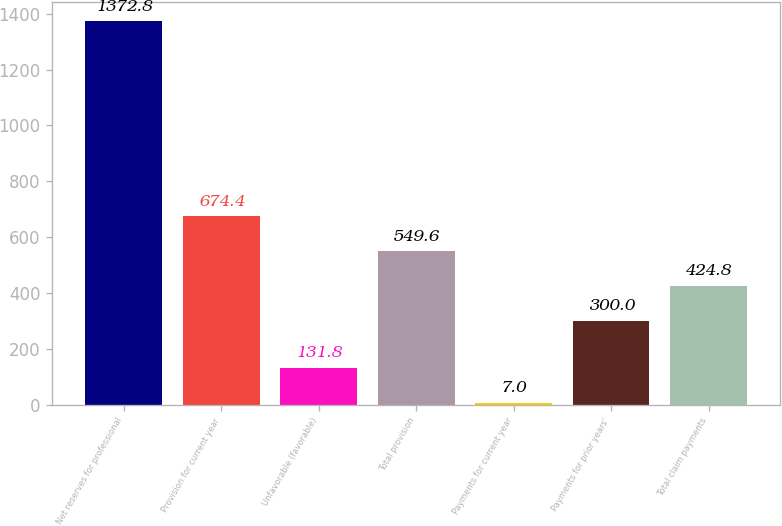<chart> <loc_0><loc_0><loc_500><loc_500><bar_chart><fcel>Net reserves for professional<fcel>Provision for current year<fcel>Unfavorable (favorable)<fcel>Total provision<fcel>Payments for current year<fcel>Payments for prior years'<fcel>Total claim payments<nl><fcel>1372.8<fcel>674.4<fcel>131.8<fcel>549.6<fcel>7<fcel>300<fcel>424.8<nl></chart> 